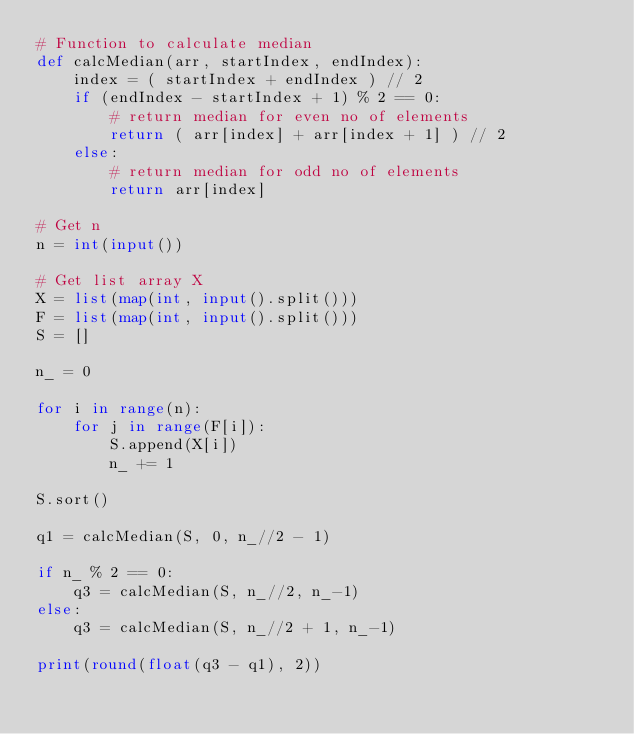<code> <loc_0><loc_0><loc_500><loc_500><_Python_># Function to calculate median
def calcMedian(arr, startIndex, endIndex):
    index = ( startIndex + endIndex ) // 2
    if (endIndex - startIndex + 1) % 2 == 0:
        # return median for even no of elements
        return ( arr[index] + arr[index + 1] ) // 2
    else:
        # return median for odd no of elements
        return arr[index]

# Get n
n = int(input())

# Get list array X
X = list(map(int, input().split()))
F = list(map(int, input().split()))
S = []

n_ = 0

for i in range(n):
    for j in range(F[i]):
        S.append(X[i])
        n_ += 1        

S.sort()

q1 = calcMedian(S, 0, n_//2 - 1)

if n_ % 2 == 0:
    q3 = calcMedian(S, n_//2, n_-1)
else:
    q3 = calcMedian(S, n_//2 + 1, n_-1)

print(round(float(q3 - q1), 2))</code> 